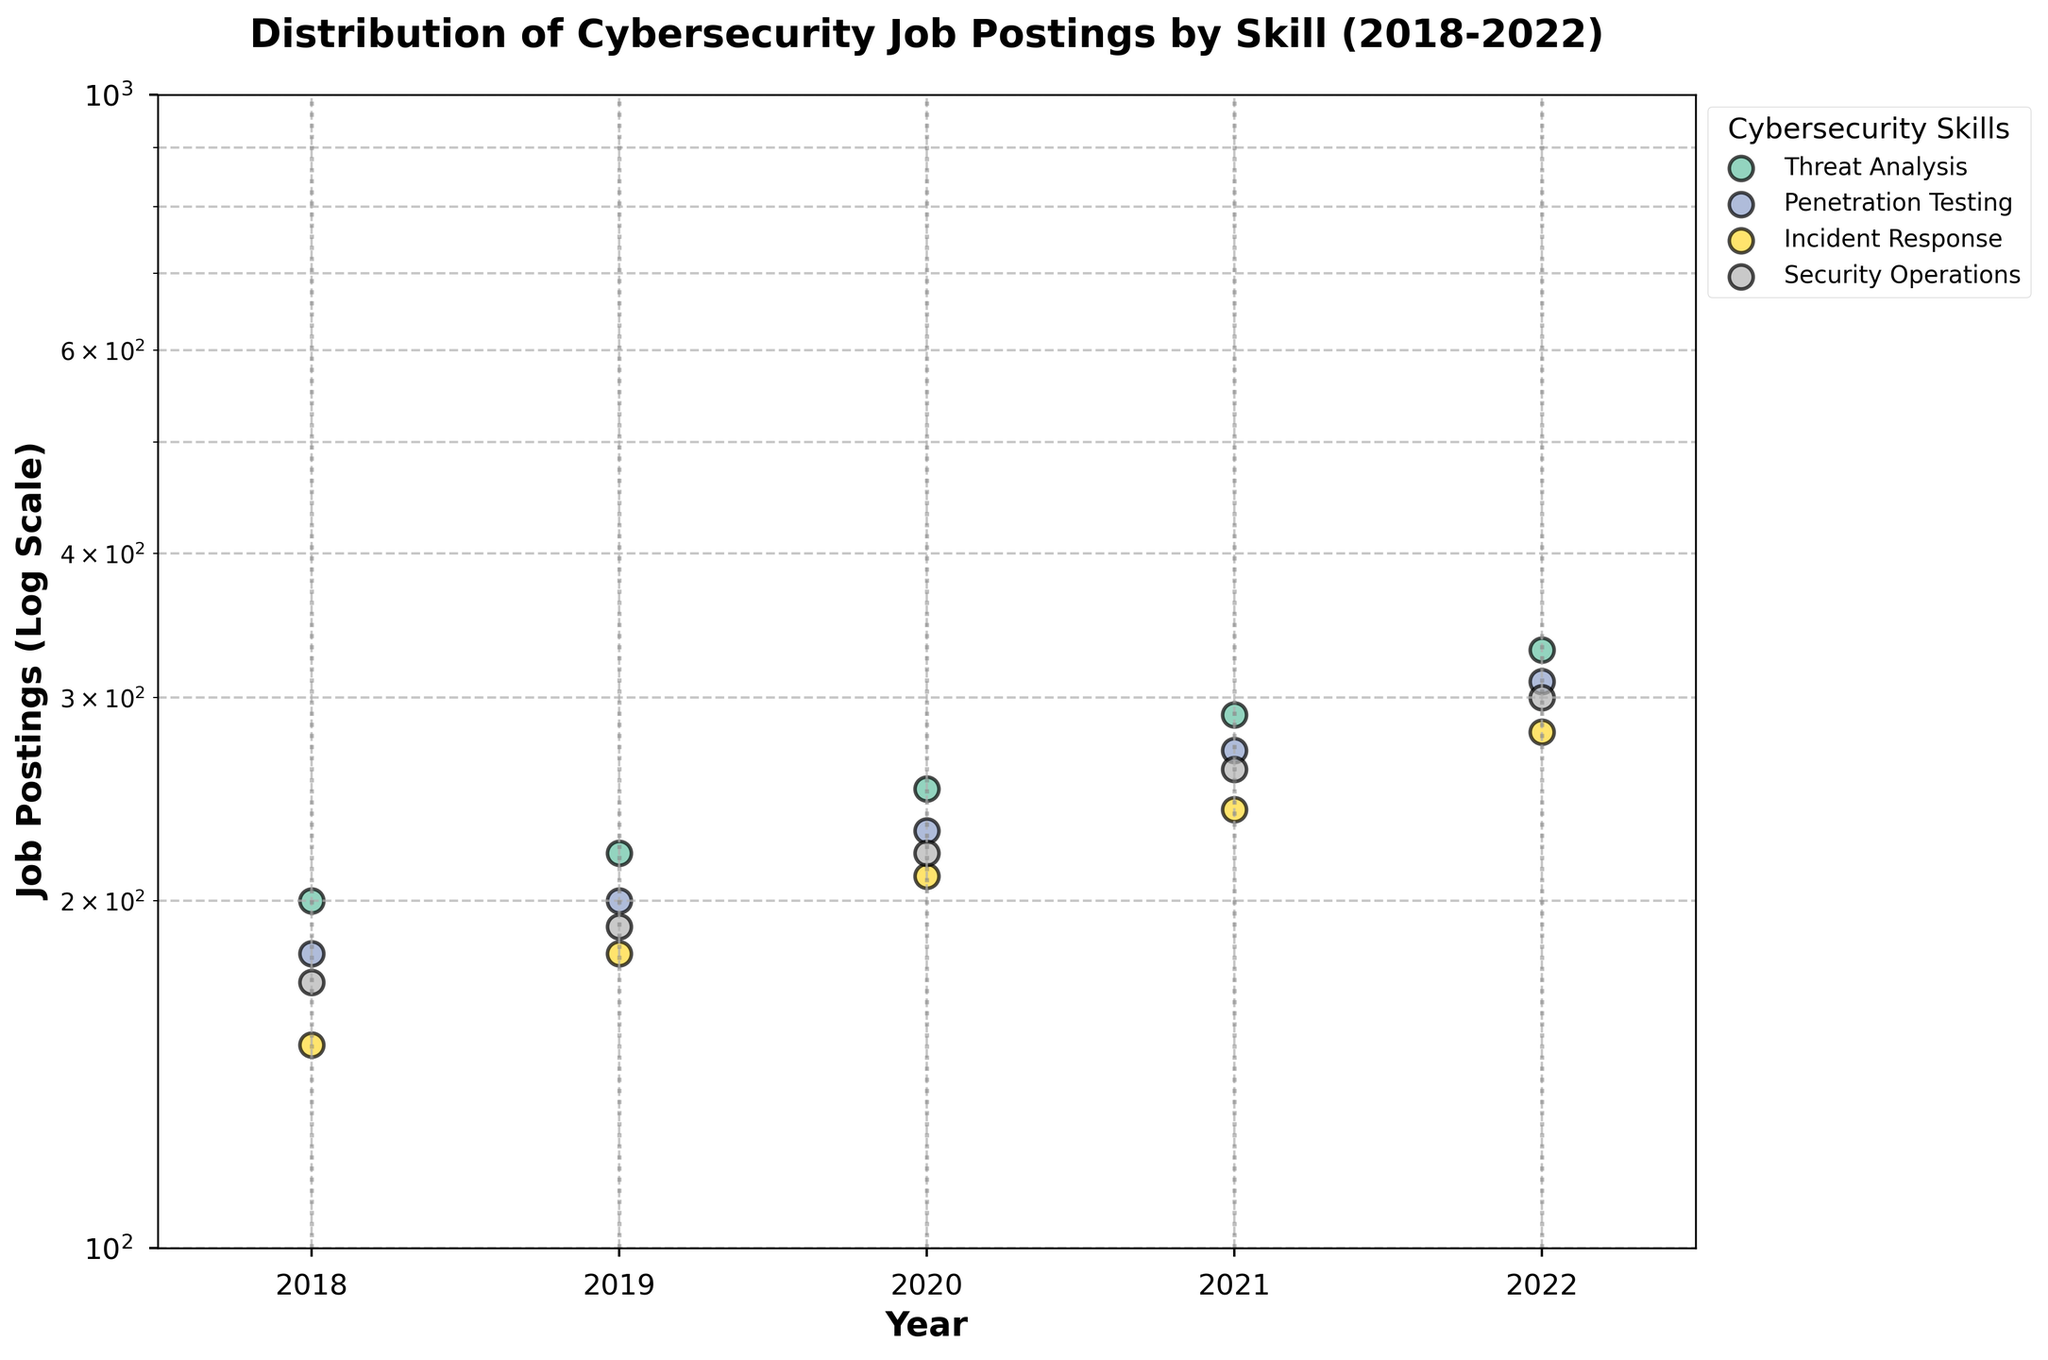what is the range of job postings for Threat Analysis in the past five years? The job postings for Threat Analysis range from 200 in 2018 to 330 in 2022.
Answer: 200 to 330 What skill experienced the highest growth in job postings from 2018 to 2022? The skill with the highest growth in job postings from 2018 to 2022 is Penetration Testing, increasing from 180 to 310.
Answer: Penetration Testing What is the general trend for the job postings requiring Incident Response over the years shown in the graph? The job postings for Incident Response show a consistent increase each year from 150 in 2018 to 280 in 2022.
Answer: Increasing Which year had the highest total number of job postings across all skills? To find the year with the highest total job postings, sum the job postings for each skill in each year. For 2022, the sum is 330 + 310 + 280 + 300 = 1220, which is the highest.
Answer: 2022 Compare the job postings for Security Operations and Threat Analysis in 2020. Which skill had more job postings? In 2020, Security Operations had 220 job postings, and Threat Analysis had 250 job postings. Therefore, Threat Analysis had more job postings.
Answer: Threat Analysis Identify the year with the smallest number of job postings for Penetration Testing and state the number. The smallest number of job postings for Penetration Testing is in 2018, with 180 job postings.
Answer: 2018, 180 How do the job postings for Security Operations change from 2019 to 2020? The job postings for Security Operations increased from 190 in 2019 to 220 in 2020.
Answer: Increased What is the average number of job postings for Incident Response across all years shown in the graph? To determine the average, sum the job postings for Incident Response each year and divide by the number of years. Average = (150 + 180 + 210 + 240 + 280) / 5 = 212.
Answer: 212 Which skill shows the most stable growth (least variation) in the number of job postings over the years? Examining the trends visually, Threat Analysis shows the most consistent year-over-year growth without large fluctuations.
Answer: Threat Analysis In which year did Threat Analysis have job postings that exceeded 300? Threat Analysis had job postings exceeding 300 in the year 2022, with 330 job postings.
Answer: 2022 